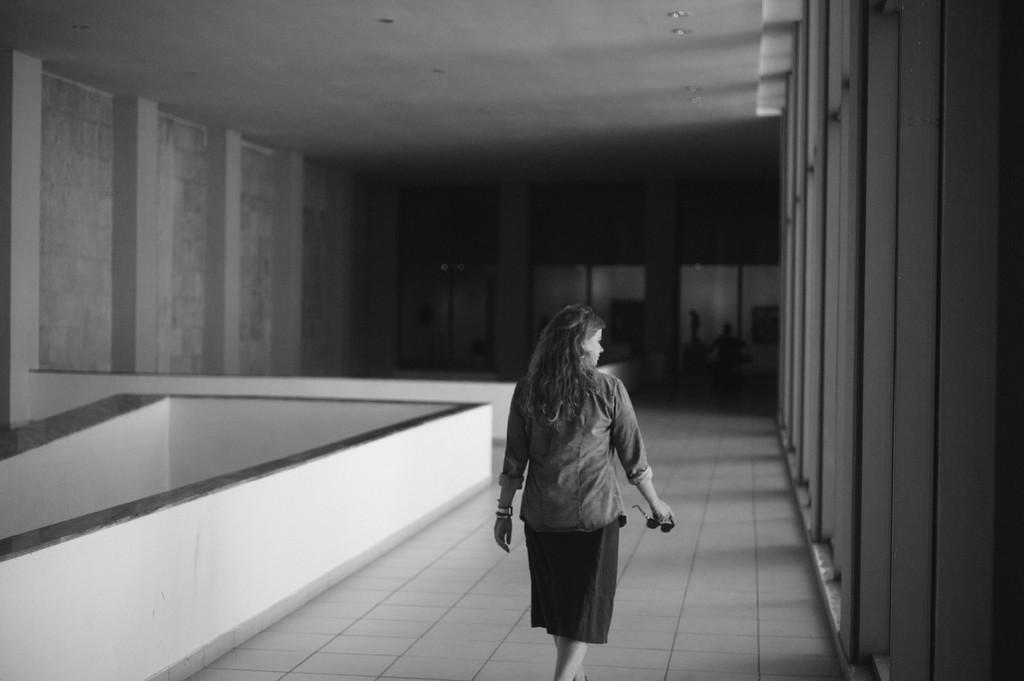What is the color scheme of the image? The image is black and white. What is the woman in the image doing? The woman is walking in the image. On what surface is the woman walking? The woman is walking on the floor. What is located beside the woman? There is a wall beside the woman. What can be seen in the background of the image? In the background, there are pillars in front of the wall. What type of owl can be seen perched on the woman's shoulder in the image? There is no owl present in the image; the woman is walking alone. How does the woman's fear of chickens affect her walk in the image? There is no mention of the woman's fear of chickens or any chickens in the image, so it cannot be determined how it affects her walk. 